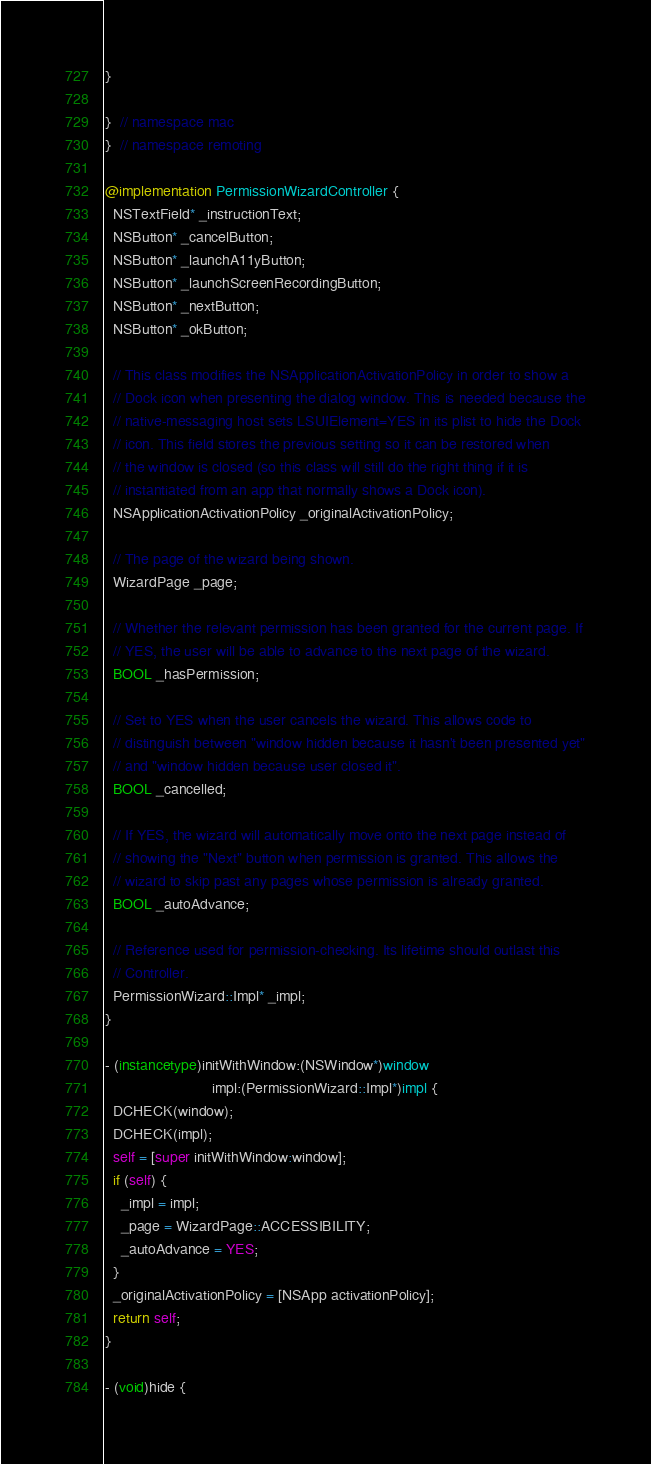<code> <loc_0><loc_0><loc_500><loc_500><_ObjectiveC_>}

}  // namespace mac
}  // namespace remoting

@implementation PermissionWizardController {
  NSTextField* _instructionText;
  NSButton* _cancelButton;
  NSButton* _launchA11yButton;
  NSButton* _launchScreenRecordingButton;
  NSButton* _nextButton;
  NSButton* _okButton;

  // This class modifies the NSApplicationActivationPolicy in order to show a
  // Dock icon when presenting the dialog window. This is needed because the
  // native-messaging host sets LSUIElement=YES in its plist to hide the Dock
  // icon. This field stores the previous setting so it can be restored when
  // the window is closed (so this class will still do the right thing if it is
  // instantiated from an app that normally shows a Dock icon).
  NSApplicationActivationPolicy _originalActivationPolicy;

  // The page of the wizard being shown.
  WizardPage _page;

  // Whether the relevant permission has been granted for the current page. If
  // YES, the user will be able to advance to the next page of the wizard.
  BOOL _hasPermission;

  // Set to YES when the user cancels the wizard. This allows code to
  // distinguish between "window hidden because it hasn't been presented yet"
  // and "window hidden because user closed it".
  BOOL _cancelled;

  // If YES, the wizard will automatically move onto the next page instead of
  // showing the "Next" button when permission is granted. This allows the
  // wizard to skip past any pages whose permission is already granted.
  BOOL _autoAdvance;

  // Reference used for permission-checking. Its lifetime should outlast this
  // Controller.
  PermissionWizard::Impl* _impl;
}

- (instancetype)initWithWindow:(NSWindow*)window
                          impl:(PermissionWizard::Impl*)impl {
  DCHECK(window);
  DCHECK(impl);
  self = [super initWithWindow:window];
  if (self) {
    _impl = impl;
    _page = WizardPage::ACCESSIBILITY;
    _autoAdvance = YES;
  }
  _originalActivationPolicy = [NSApp activationPolicy];
  return self;
}

- (void)hide {</code> 